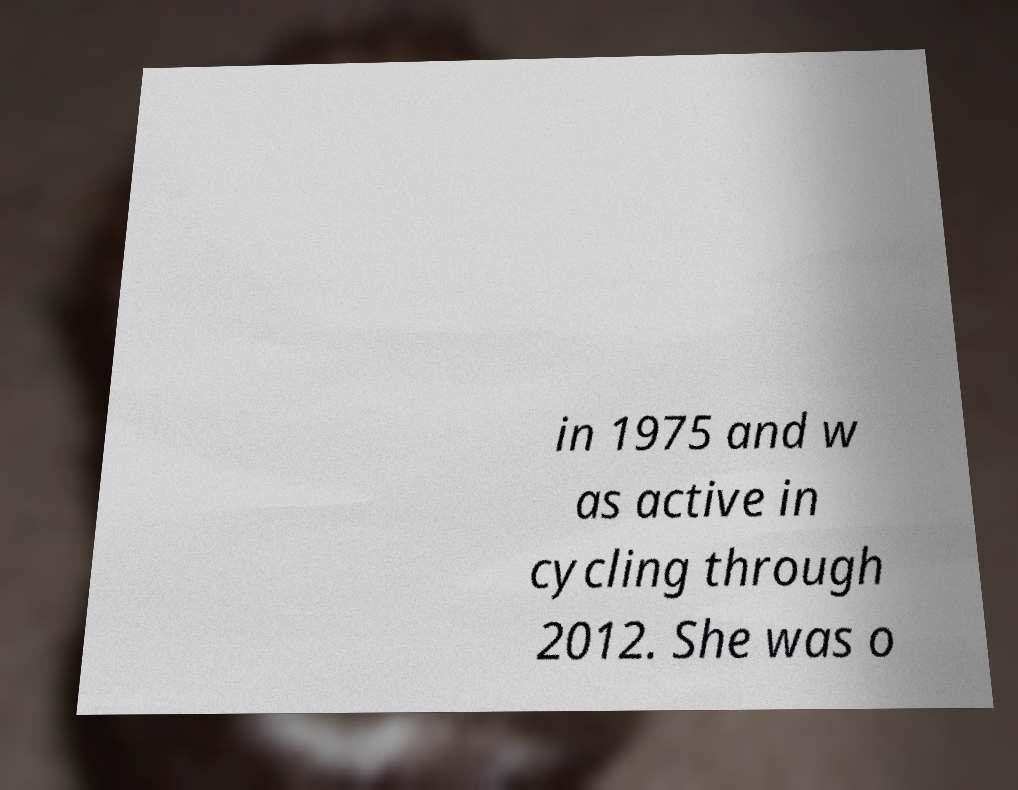Can you read and provide the text displayed in the image?This photo seems to have some interesting text. Can you extract and type it out for me? in 1975 and w as active in cycling through 2012. She was o 